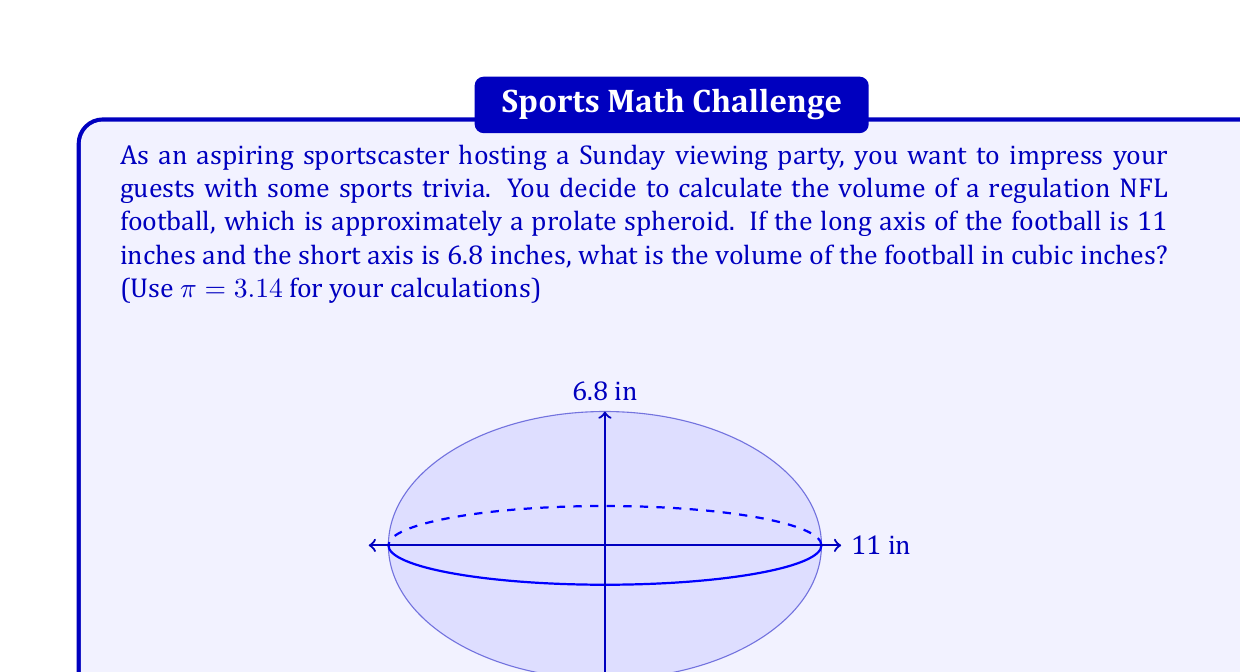Provide a solution to this math problem. To solve this problem, we need to use the formula for the volume of a prolate spheroid:

$$V = \frac{4}{3}\pi a b^2$$

Where:
$a$ is half the length of the long axis
$b$ is half the length of the short axis

Let's break it down step by step:

1) First, we need to determine $a$ and $b$:
   $a = 11 \div 2 = 5.5$ inches
   $b = 6.8 \div 2 = 3.4$ inches

2) Now, let's substitute these values into our formula:
   $$V = \frac{4}{3}\pi (5.5)(3.4)^2$$

3) Let's calculate the inside of the parentheses first:
   $$V = \frac{4}{3}\pi (5.5)(11.56)$$
   $$V = \frac{4}{3}\pi (63.58)$$

4) Now, let's multiply by $\pi$ (using 3.14):
   $$V = \frac{4}{3} (199.6412)$$

5) Finally, let's multiply by $\frac{4}{3}$:
   $$V = 266.1883$$

6) Rounding to two decimal places:
   $$V \approx 266.19\text{ cubic inches}$$
Answer: The volume of the NFL football is approximately 266.19 cubic inches. 